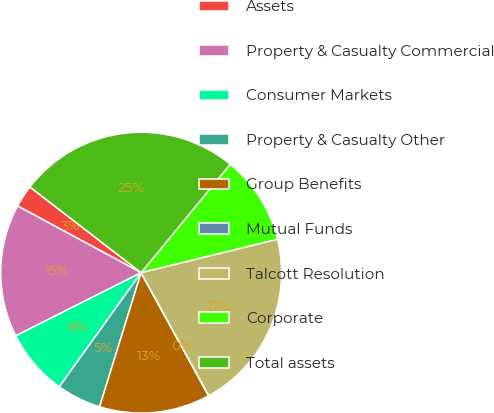Convert chart to OTSL. <chart><loc_0><loc_0><loc_500><loc_500><pie_chart><fcel>Assets<fcel>Property & Casualty Commercial<fcel>Consumer Markets<fcel>Property & Casualty Other<fcel>Group Benefits<fcel>Mutual Funds<fcel>Talcott Resolution<fcel>Corporate<fcel>Total assets<nl><fcel>2.57%<fcel>15.31%<fcel>7.67%<fcel>5.12%<fcel>12.76%<fcel>0.03%<fcel>20.83%<fcel>10.22%<fcel>25.5%<nl></chart> 